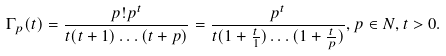Convert formula to latex. <formula><loc_0><loc_0><loc_500><loc_500>\Gamma _ { p } ( t ) = \frac { p ! p ^ { t } } { t ( t + 1 ) \dots ( t + p ) } = \frac { p ^ { t } } { t ( 1 + \frac { t } { 1 } ) \dots ( 1 + \frac { t } { p } ) } , p \in N , t > 0 .</formula> 